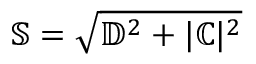Convert formula to latex. <formula><loc_0><loc_0><loc_500><loc_500>\mathbb { S } = \sqrt { \mathbb { D } ^ { 2 } + | \mathbb { C } | ^ { 2 } }</formula> 